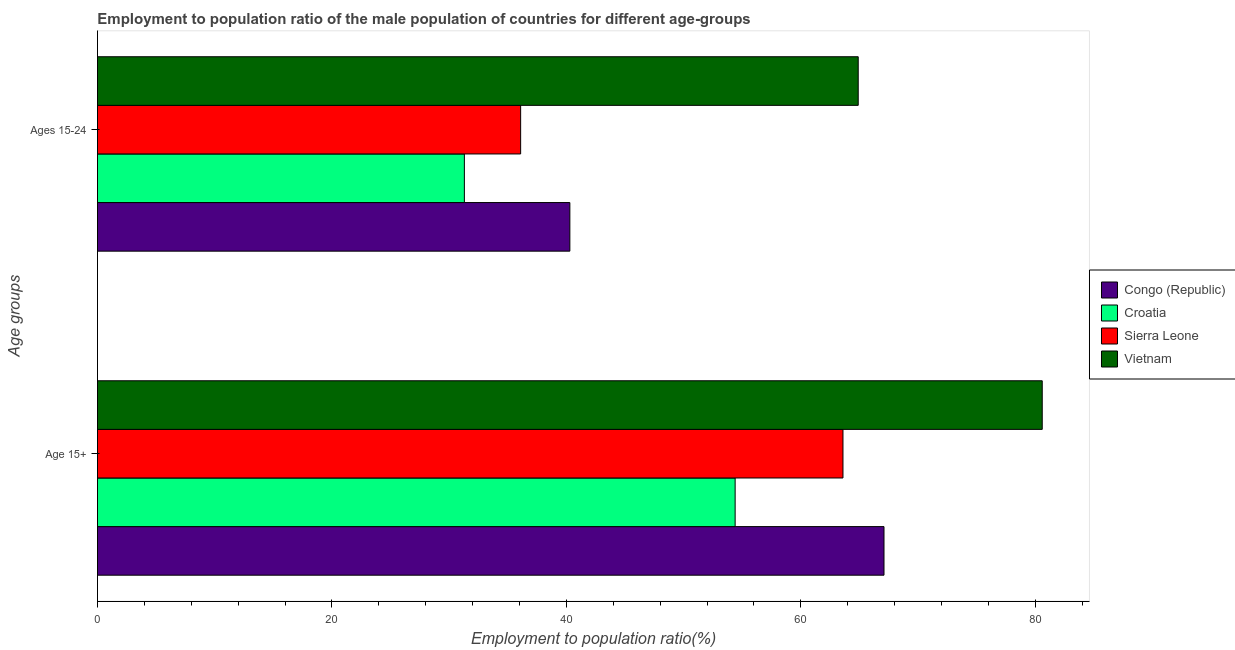How many different coloured bars are there?
Provide a succinct answer. 4. Are the number of bars on each tick of the Y-axis equal?
Keep it short and to the point. Yes. How many bars are there on the 1st tick from the top?
Provide a short and direct response. 4. What is the label of the 1st group of bars from the top?
Your answer should be compact. Ages 15-24. What is the employment to population ratio(age 15+) in Croatia?
Ensure brevity in your answer.  54.4. Across all countries, what is the maximum employment to population ratio(age 15+)?
Your answer should be compact. 80.6. Across all countries, what is the minimum employment to population ratio(age 15-24)?
Give a very brief answer. 31.3. In which country was the employment to population ratio(age 15-24) maximum?
Make the answer very short. Vietnam. In which country was the employment to population ratio(age 15-24) minimum?
Give a very brief answer. Croatia. What is the total employment to population ratio(age 15+) in the graph?
Ensure brevity in your answer.  265.7. What is the difference between the employment to population ratio(age 15-24) in Vietnam and that in Croatia?
Keep it short and to the point. 33.6. What is the difference between the employment to population ratio(age 15+) in Vietnam and the employment to population ratio(age 15-24) in Sierra Leone?
Offer a terse response. 44.5. What is the average employment to population ratio(age 15+) per country?
Your answer should be very brief. 66.42. What is the difference between the employment to population ratio(age 15-24) and employment to population ratio(age 15+) in Vietnam?
Give a very brief answer. -15.7. What is the ratio of the employment to population ratio(age 15-24) in Vietnam to that in Sierra Leone?
Provide a short and direct response. 1.8. What does the 4th bar from the top in Age 15+ represents?
Provide a succinct answer. Congo (Republic). What does the 4th bar from the bottom in Age 15+ represents?
Your answer should be compact. Vietnam. How many countries are there in the graph?
Ensure brevity in your answer.  4. Are the values on the major ticks of X-axis written in scientific E-notation?
Ensure brevity in your answer.  No. Does the graph contain any zero values?
Provide a short and direct response. No. Does the graph contain grids?
Give a very brief answer. No. Where does the legend appear in the graph?
Offer a very short reply. Center right. How many legend labels are there?
Offer a terse response. 4. How are the legend labels stacked?
Provide a short and direct response. Vertical. What is the title of the graph?
Offer a terse response. Employment to population ratio of the male population of countries for different age-groups. Does "Curacao" appear as one of the legend labels in the graph?
Make the answer very short. No. What is the label or title of the Y-axis?
Offer a very short reply. Age groups. What is the Employment to population ratio(%) in Congo (Republic) in Age 15+?
Provide a succinct answer. 67.1. What is the Employment to population ratio(%) in Croatia in Age 15+?
Keep it short and to the point. 54.4. What is the Employment to population ratio(%) of Sierra Leone in Age 15+?
Make the answer very short. 63.6. What is the Employment to population ratio(%) of Vietnam in Age 15+?
Provide a succinct answer. 80.6. What is the Employment to population ratio(%) of Congo (Republic) in Ages 15-24?
Provide a short and direct response. 40.3. What is the Employment to population ratio(%) of Croatia in Ages 15-24?
Give a very brief answer. 31.3. What is the Employment to population ratio(%) in Sierra Leone in Ages 15-24?
Give a very brief answer. 36.1. What is the Employment to population ratio(%) of Vietnam in Ages 15-24?
Provide a succinct answer. 64.9. Across all Age groups, what is the maximum Employment to population ratio(%) of Congo (Republic)?
Ensure brevity in your answer.  67.1. Across all Age groups, what is the maximum Employment to population ratio(%) in Croatia?
Your answer should be very brief. 54.4. Across all Age groups, what is the maximum Employment to population ratio(%) of Sierra Leone?
Provide a succinct answer. 63.6. Across all Age groups, what is the maximum Employment to population ratio(%) of Vietnam?
Your answer should be very brief. 80.6. Across all Age groups, what is the minimum Employment to population ratio(%) in Congo (Republic)?
Keep it short and to the point. 40.3. Across all Age groups, what is the minimum Employment to population ratio(%) in Croatia?
Your response must be concise. 31.3. Across all Age groups, what is the minimum Employment to population ratio(%) in Sierra Leone?
Offer a very short reply. 36.1. Across all Age groups, what is the minimum Employment to population ratio(%) in Vietnam?
Your answer should be very brief. 64.9. What is the total Employment to population ratio(%) in Congo (Republic) in the graph?
Give a very brief answer. 107.4. What is the total Employment to population ratio(%) in Croatia in the graph?
Provide a short and direct response. 85.7. What is the total Employment to population ratio(%) in Sierra Leone in the graph?
Your response must be concise. 99.7. What is the total Employment to population ratio(%) of Vietnam in the graph?
Your response must be concise. 145.5. What is the difference between the Employment to population ratio(%) in Congo (Republic) in Age 15+ and that in Ages 15-24?
Your response must be concise. 26.8. What is the difference between the Employment to population ratio(%) in Croatia in Age 15+ and that in Ages 15-24?
Your answer should be compact. 23.1. What is the difference between the Employment to population ratio(%) in Congo (Republic) in Age 15+ and the Employment to population ratio(%) in Croatia in Ages 15-24?
Offer a very short reply. 35.8. What is the difference between the Employment to population ratio(%) in Croatia in Age 15+ and the Employment to population ratio(%) in Sierra Leone in Ages 15-24?
Offer a very short reply. 18.3. What is the difference between the Employment to population ratio(%) of Croatia in Age 15+ and the Employment to population ratio(%) of Vietnam in Ages 15-24?
Make the answer very short. -10.5. What is the difference between the Employment to population ratio(%) in Sierra Leone in Age 15+ and the Employment to population ratio(%) in Vietnam in Ages 15-24?
Provide a short and direct response. -1.3. What is the average Employment to population ratio(%) in Congo (Republic) per Age groups?
Make the answer very short. 53.7. What is the average Employment to population ratio(%) in Croatia per Age groups?
Your response must be concise. 42.85. What is the average Employment to population ratio(%) of Sierra Leone per Age groups?
Your answer should be compact. 49.85. What is the average Employment to population ratio(%) of Vietnam per Age groups?
Offer a terse response. 72.75. What is the difference between the Employment to population ratio(%) in Congo (Republic) and Employment to population ratio(%) in Sierra Leone in Age 15+?
Your answer should be very brief. 3.5. What is the difference between the Employment to population ratio(%) in Congo (Republic) and Employment to population ratio(%) in Vietnam in Age 15+?
Your response must be concise. -13.5. What is the difference between the Employment to population ratio(%) of Croatia and Employment to population ratio(%) of Sierra Leone in Age 15+?
Provide a succinct answer. -9.2. What is the difference between the Employment to population ratio(%) of Croatia and Employment to population ratio(%) of Vietnam in Age 15+?
Keep it short and to the point. -26.2. What is the difference between the Employment to population ratio(%) in Congo (Republic) and Employment to population ratio(%) in Croatia in Ages 15-24?
Provide a short and direct response. 9. What is the difference between the Employment to population ratio(%) of Congo (Republic) and Employment to population ratio(%) of Sierra Leone in Ages 15-24?
Your answer should be very brief. 4.2. What is the difference between the Employment to population ratio(%) in Congo (Republic) and Employment to population ratio(%) in Vietnam in Ages 15-24?
Offer a terse response. -24.6. What is the difference between the Employment to population ratio(%) in Croatia and Employment to population ratio(%) in Sierra Leone in Ages 15-24?
Your answer should be compact. -4.8. What is the difference between the Employment to population ratio(%) in Croatia and Employment to population ratio(%) in Vietnam in Ages 15-24?
Ensure brevity in your answer.  -33.6. What is the difference between the Employment to population ratio(%) of Sierra Leone and Employment to population ratio(%) of Vietnam in Ages 15-24?
Give a very brief answer. -28.8. What is the ratio of the Employment to population ratio(%) of Congo (Republic) in Age 15+ to that in Ages 15-24?
Give a very brief answer. 1.67. What is the ratio of the Employment to population ratio(%) in Croatia in Age 15+ to that in Ages 15-24?
Ensure brevity in your answer.  1.74. What is the ratio of the Employment to population ratio(%) of Sierra Leone in Age 15+ to that in Ages 15-24?
Give a very brief answer. 1.76. What is the ratio of the Employment to population ratio(%) of Vietnam in Age 15+ to that in Ages 15-24?
Your response must be concise. 1.24. What is the difference between the highest and the second highest Employment to population ratio(%) of Congo (Republic)?
Provide a succinct answer. 26.8. What is the difference between the highest and the second highest Employment to population ratio(%) of Croatia?
Give a very brief answer. 23.1. What is the difference between the highest and the second highest Employment to population ratio(%) in Vietnam?
Offer a terse response. 15.7. What is the difference between the highest and the lowest Employment to population ratio(%) of Congo (Republic)?
Ensure brevity in your answer.  26.8. What is the difference between the highest and the lowest Employment to population ratio(%) in Croatia?
Give a very brief answer. 23.1. 